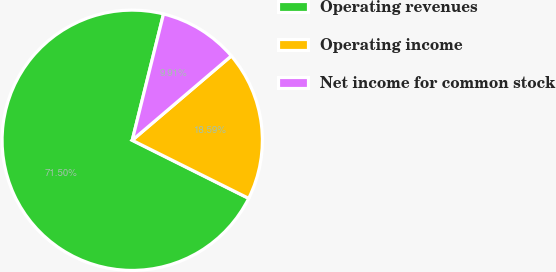Convert chart to OTSL. <chart><loc_0><loc_0><loc_500><loc_500><pie_chart><fcel>Operating revenues<fcel>Operating income<fcel>Net income for common stock<nl><fcel>71.5%<fcel>18.59%<fcel>9.91%<nl></chart> 